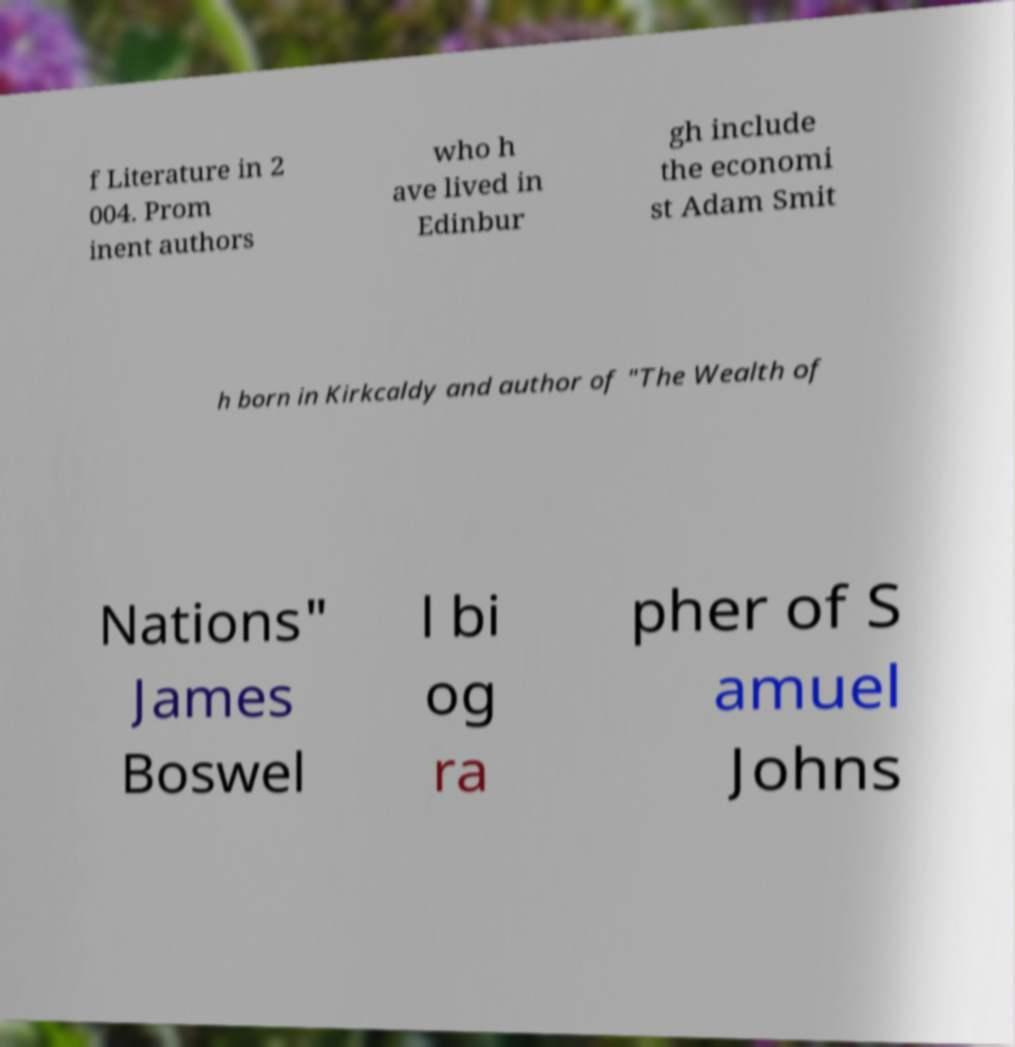Please identify and transcribe the text found in this image. f Literature in 2 004. Prom inent authors who h ave lived in Edinbur gh include the economi st Adam Smit h born in Kirkcaldy and author of "The Wealth of Nations" James Boswel l bi og ra pher of S amuel Johns 